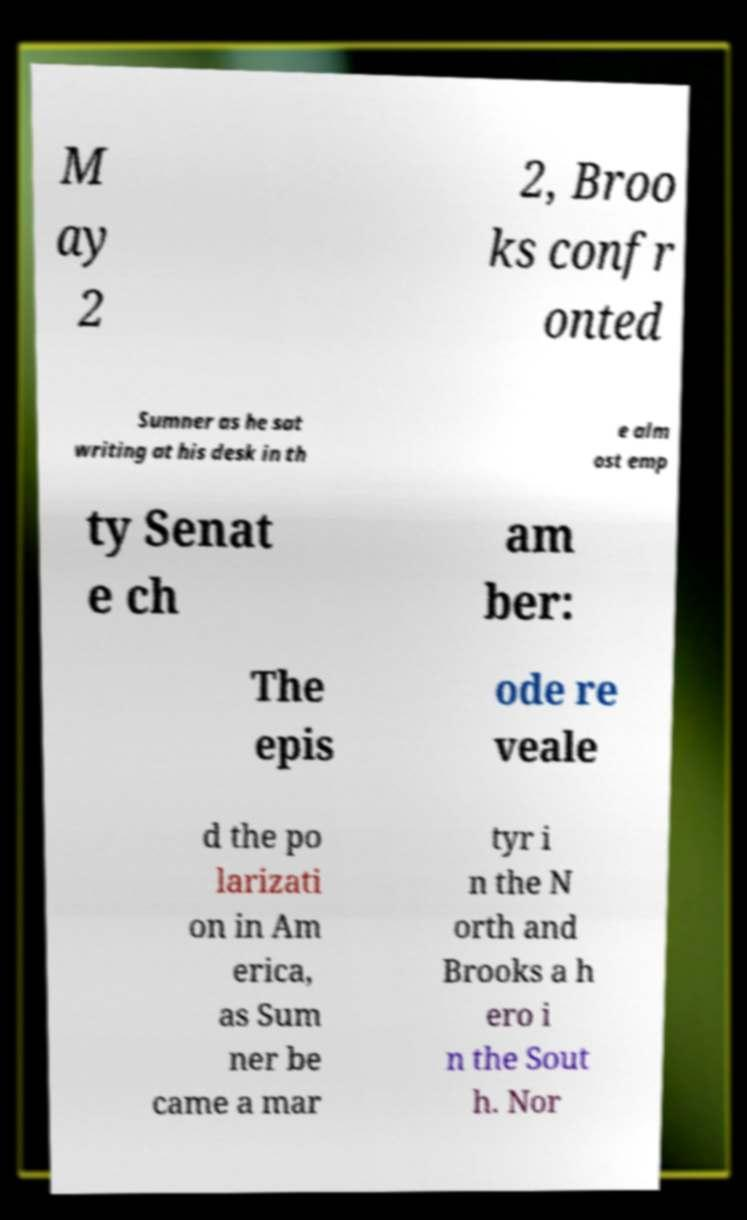Could you extract and type out the text from this image? M ay 2 2, Broo ks confr onted Sumner as he sat writing at his desk in th e alm ost emp ty Senat e ch am ber: The epis ode re veale d the po larizati on in Am erica, as Sum ner be came a mar tyr i n the N orth and Brooks a h ero i n the Sout h. Nor 